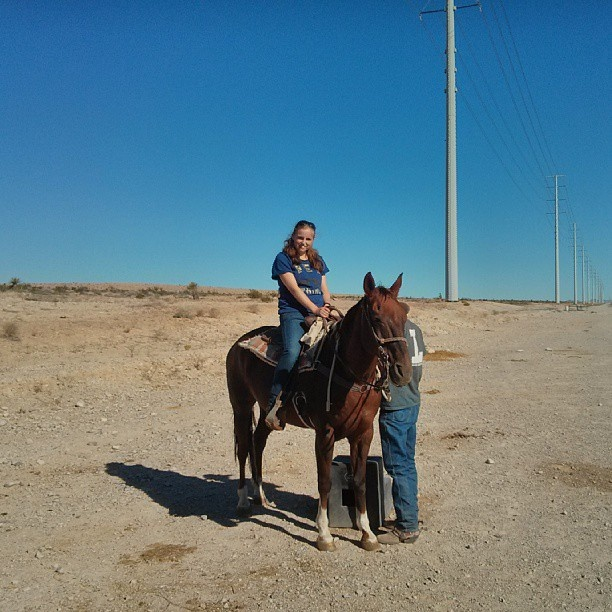Describe the objects in this image and their specific colors. I can see horse in blue, black, maroon, and gray tones, people in blue, gray, black, and darkblue tones, and people in blue, black, navy, and gray tones in this image. 